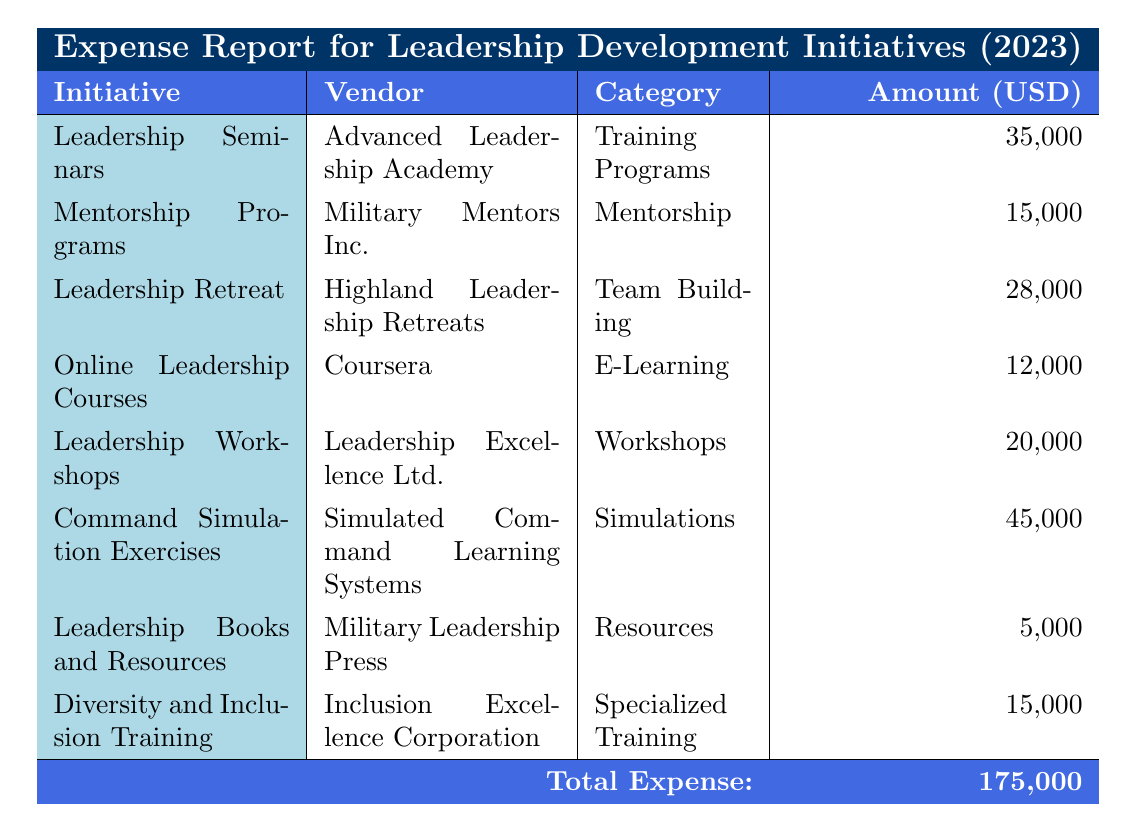What is the total amount allocated for Leadership Seminars? The table states that the amount for Leadership Seminars is 35,000 USD.
Answer: 35,000 USD Which initiative has the highest expense? By reviewing the table, we can see that Command Simulation Exercises has the highest expense of 45,000 USD.
Answer: Command Simulation Exercises What is the average expense for the mentorship-related initiatives? The mentorship-related initiatives are Mentorship Programs (15,000 USD) and Diversity and Inclusion Training (15,000 USD), so the average is (15,000 + 15,000) / 2 = 15,000.
Answer: 15,000 USD Is the total expense greater than 150,000 USD? The total expense is clearly stated as 175,000 USD, which is greater than 150,000 USD.
Answer: Yes How much more is spent on Leadership Retreats compared to Online Leadership Courses? Leadership Retreats amount to 28,000 USD and Online Leadership Courses amount to 12,000 USD. The difference is 28,000 - 12,000 = 16,000 USD.
Answer: 16,000 USD How many initiatives are categorized under training-related programs? The table shows that there are four initiatives under training-related categories: Leadership Seminars, Mentorship Programs, Leadership Workshops, and Diversity and Inclusion Training.
Answer: 4 What percentage of the total expense is allocated to Command Simulation Exercises? Command Simulation Exercises cost 45,000 USD. To find the percentage of the total expense (175,000 USD), we calculate (45,000 / 175,000) * 100 = 25.71%.
Answer: 25.71% Is there any initiative that costs less than 10,000 USD? The least expensive initiative listed is Leadership Books and Resources, which costs 5,000 USD, thus confirming that there is at least one initiative costing less than 10,000 USD.
Answer: Yes What is the total expense for all training-related initiatives? The training-related initiatives are Leadership Seminars (35,000 USD), Leadership Workshops (20,000 USD), and Diversity and Inclusion Training (15,000 USD). Summing these gives 35,000 + 20,000 + 15,000 = 70,000 USD.
Answer: 70,000 USD 